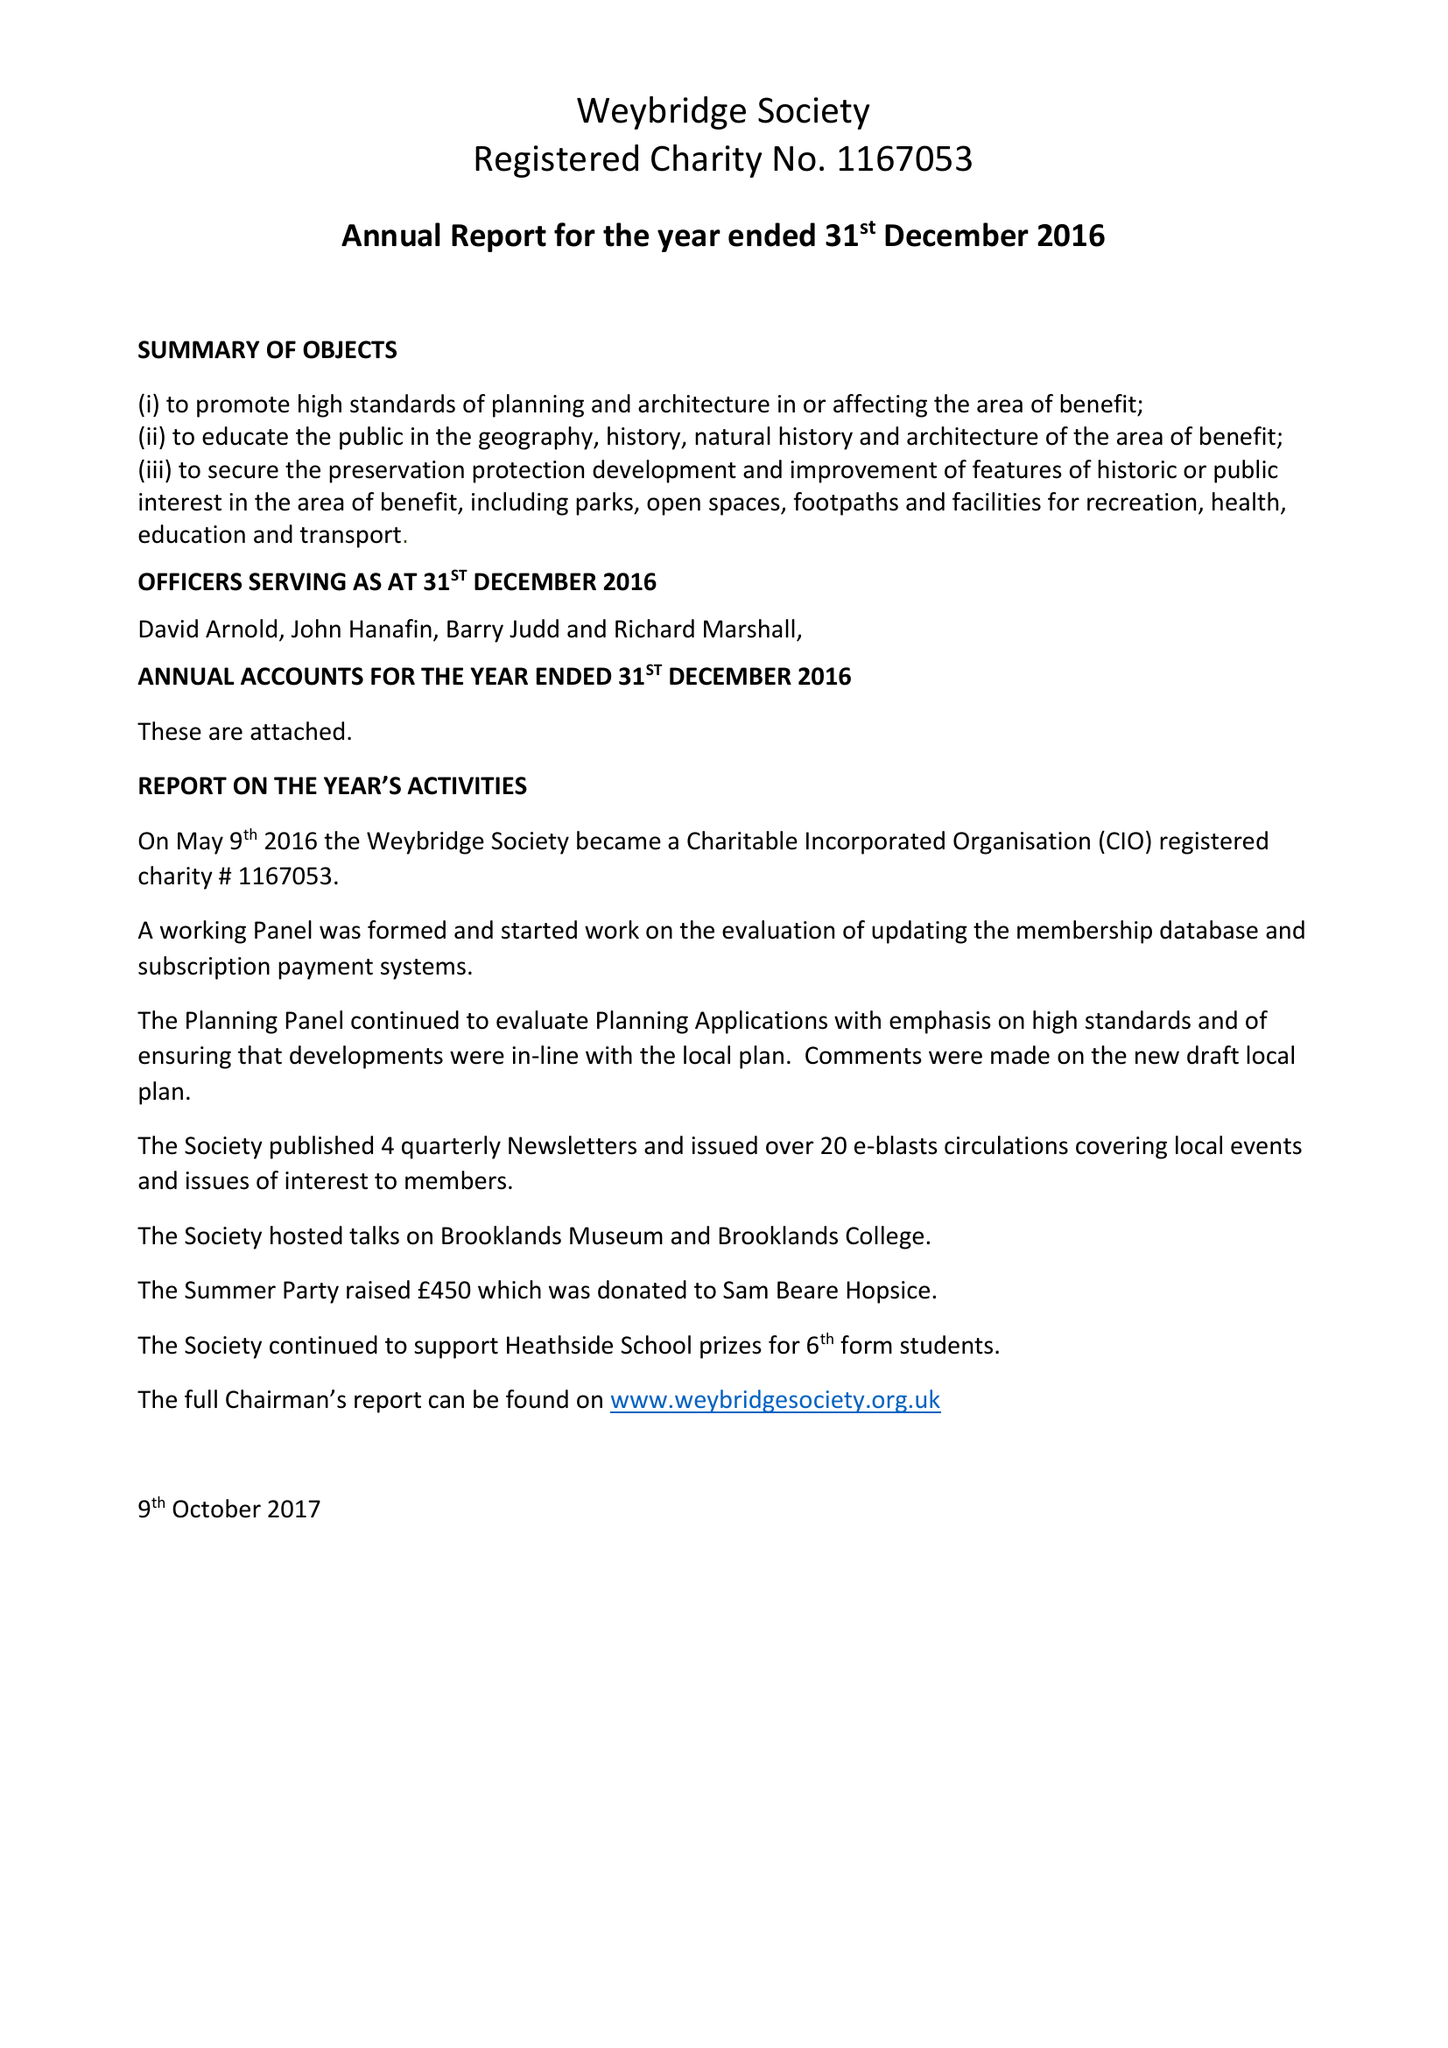What is the value for the address__post_town?
Answer the question using a single word or phrase. None 